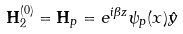<formula> <loc_0><loc_0><loc_500><loc_500>\mathbf H _ { 2 } ^ { ( 0 ) } = \mathbf H _ { p } = e ^ { i \beta z } \psi _ { p } ( x ) \hat { y }</formula> 